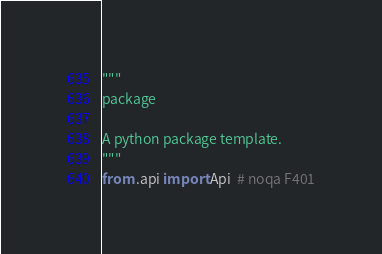Convert code to text. <code><loc_0><loc_0><loc_500><loc_500><_Python_>"""
package

A python package template.
"""
from .api import Api  # noqa F401
</code> 